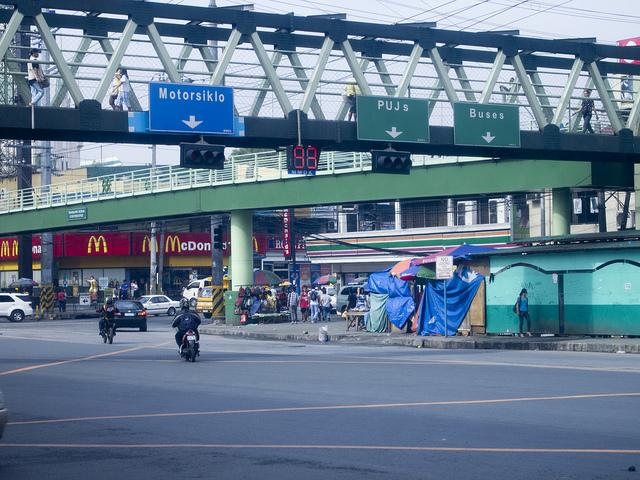What is the meaning of the arrows on the sign? Please explain your reasoning. go straight. It is letting people know to stay in those lanes going that direction for different places they need to be 